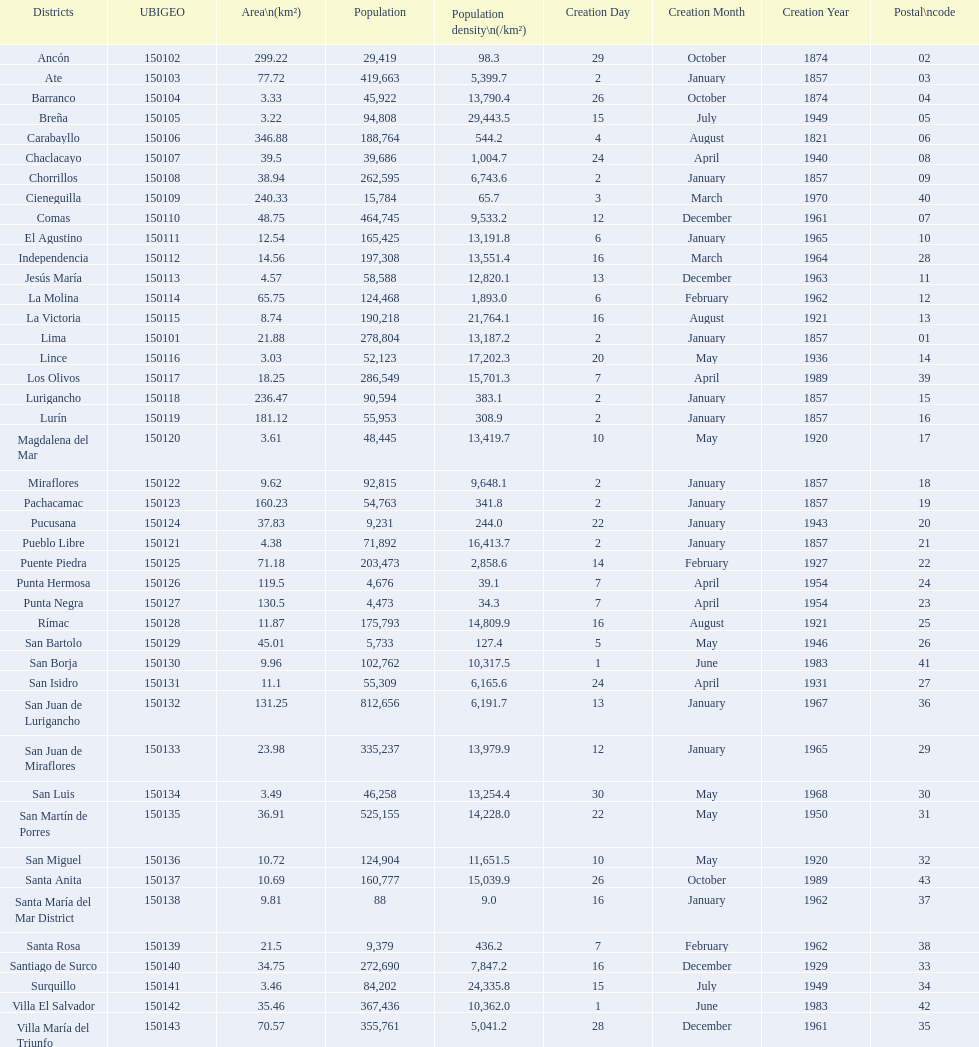What is the total number of districts created in the 1900's? 32. Write the full table. {'header': ['Districts', 'UBIGEO', 'Area\\n(km²)', 'Population', 'Population density\\n(/km²)', 'Creation Day', 'Creation Month', 'Creation Year', 'Postal\\ncode'], 'rows': [['Ancón', '150102', '299.22', '29,419', '98.3', '29', 'October', '1874', '02'], ['Ate', '150103', '77.72', '419,663', '5,399.7', '2', 'January', '1857', '03'], ['Barranco', '150104', '3.33', '45,922', '13,790.4', '26', 'October', '1874', '04'], ['Breña', '150105', '3.22', '94,808', '29,443.5', '15', 'July', '1949', '05'], ['Carabayllo', '150106', '346.88', '188,764', '544.2', '4', 'August', '1821', '06'], ['Chaclacayo', '150107', '39.5', '39,686', '1,004.7', '24', 'April', '1940', '08'], ['Chorrillos', '150108', '38.94', '262,595', '6,743.6', '2', 'January', '1857', '09'], ['Cieneguilla', '150109', '240.33', '15,784', '65.7', '3', 'March', '1970', '40'], ['Comas', '150110', '48.75', '464,745', '9,533.2', '12', 'December', '1961', '07'], ['El Agustino', '150111', '12.54', '165,425', '13,191.8', '6', 'January', '1965', '10'], ['Independencia', '150112', '14.56', '197,308', '13,551.4', '16', 'March', '1964', '28'], ['Jesús María', '150113', '4.57', '58,588', '12,820.1', '13', 'December', '1963', '11'], ['La Molina', '150114', '65.75', '124,468', '1,893.0', '6', 'February', '1962', '12'], ['La Victoria', '150115', '8.74', '190,218', '21,764.1', '16', 'August', '1921', '13'], ['Lima', '150101', '21.88', '278,804', '13,187.2', '2', 'January', '1857', '01'], ['Lince', '150116', '3.03', '52,123', '17,202.3', '20', 'May', '1936', '14'], ['Los Olivos', '150117', '18.25', '286,549', '15,701.3', '7', 'April', '1989', '39'], ['Lurigancho', '150118', '236.47', '90,594', '383.1', '2', 'January', '1857', '15'], ['Lurín', '150119', '181.12', '55,953', '308.9', '2', 'January', '1857', '16'], ['Magdalena del Mar', '150120', '3.61', '48,445', '13,419.7', '10', 'May', '1920', '17'], ['Miraflores', '150122', '9.62', '92,815', '9,648.1', '2', 'January', '1857', '18'], ['Pachacamac', '150123', '160.23', '54,763', '341.8', '2', 'January', '1857', '19'], ['Pucusana', '150124', '37.83', '9,231', '244.0', '22', 'January', '1943', '20'], ['Pueblo Libre', '150121', '4.38', '71,892', '16,413.7', '2', 'January', '1857', '21'], ['Puente Piedra', '150125', '71.18', '203,473', '2,858.6', '14', 'February', '1927', '22'], ['Punta Hermosa', '150126', '119.5', '4,676', '39.1', '7', 'April', '1954', '24'], ['Punta Negra', '150127', '130.5', '4,473', '34.3', '7', 'April', '1954', '23'], ['Rímac', '150128', '11.87', '175,793', '14,809.9', '16', 'August', '1921', '25'], ['San Bartolo', '150129', '45.01', '5,733', '127.4', '5', 'May', '1946', '26'], ['San Borja', '150130', '9.96', '102,762', '10,317.5', '1', 'June', '1983', '41'], ['San Isidro', '150131', '11.1', '55,309', '6,165.6', '24', 'April', '1931', '27'], ['San Juan de Lurigancho', '150132', '131.25', '812,656', '6,191.7', '13', 'January', '1967', '36'], ['San Juan de Miraflores', '150133', '23.98', '335,237', '13,979.9', '12', 'January', '1965', '29'], ['San Luis', '150134', '3.49', '46,258', '13,254.4', '30', 'May', '1968', '30'], ['San Martín de Porres', '150135', '36.91', '525,155', '14,228.0', '22', 'May', '1950', '31'], ['San Miguel', '150136', '10.72', '124,904', '11,651.5', '10', 'May', '1920', '32'], ['Santa Anita', '150137', '10.69', '160,777', '15,039.9', '26', 'October', '1989', '43'], ['Santa María del Mar District', '150138', '9.81', '88', '9.0', '16', 'January', '1962', '37'], ['Santa Rosa', '150139', '21.5', '9,379', '436.2', '7', 'February', '1962', '38'], ['Santiago de Surco', '150140', '34.75', '272,690', '7,847.2', '16', 'December', '1929', '33'], ['Surquillo', '150141', '3.46', '84,202', '24,335.8', '15', 'July', '1949', '34'], ['Villa El Salvador', '150142', '35.46', '367,436', '10,362.0', '1', 'June', '1983', '42'], ['Villa María del Triunfo', '150143', '70.57', '355,761', '5,041.2', '28', 'December', '1961', '35']]} 